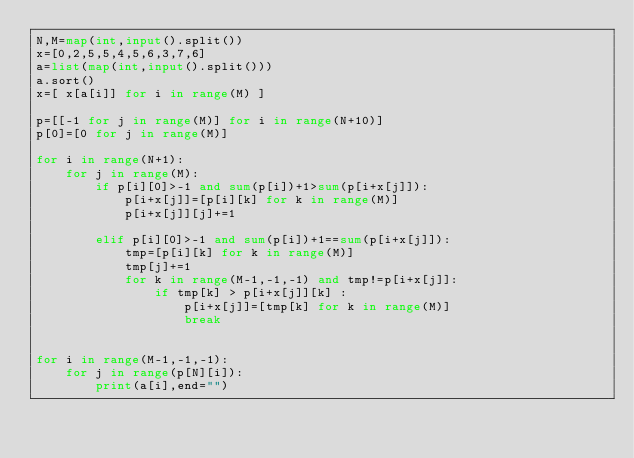Convert code to text. <code><loc_0><loc_0><loc_500><loc_500><_Python_>N,M=map(int,input().split())
x=[0,2,5,5,4,5,6,3,7,6]
a=list(map(int,input().split()))
a.sort()
x=[ x[a[i]] for i in range(M) ]

p=[[-1 for j in range(M)] for i in range(N+10)]
p[0]=[0 for j in range(M)]

for i in range(N+1):
    for j in range(M):
        if p[i][0]>-1 and sum(p[i])+1>sum(p[i+x[j]]):
            p[i+x[j]]=[p[i][k] for k in range(M)]
            p[i+x[j]][j]+=1

        elif p[i][0]>-1 and sum(p[i])+1==sum(p[i+x[j]]):
            tmp=[p[i][k] for k in range(M)]
            tmp[j]+=1
            for k in range(M-1,-1,-1) and tmp!=p[i+x[j]]:
                if tmp[k] > p[i+x[j]][k] :
                    p[i+x[j]]=[tmp[k] for k in range(M)]
                    break


for i in range(M-1,-1,-1):
    for j in range(p[N][i]):
        print(a[i],end="")</code> 